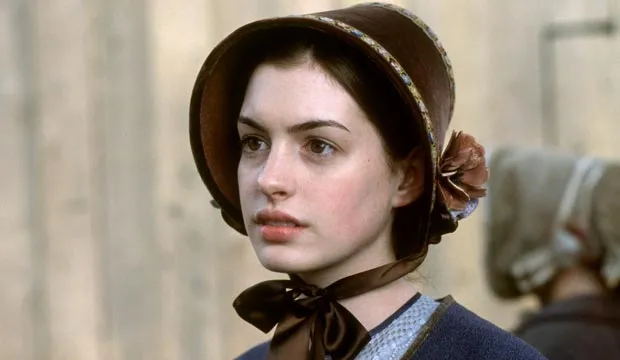What do you think is going on in this snapshot?
 In this image, we see the actress Anne Hathaway, known for her role in the movie "Becoming Jane". She is standing in front of a stone building, her gaze directed off to the side, embodying a serious expression. Dressed in a period costume, she is wearing a blue dress complemented by a brown bonnet and a black ribbon tied around her neck. A blurred figure can be seen in the background, adding depth to the scene. 